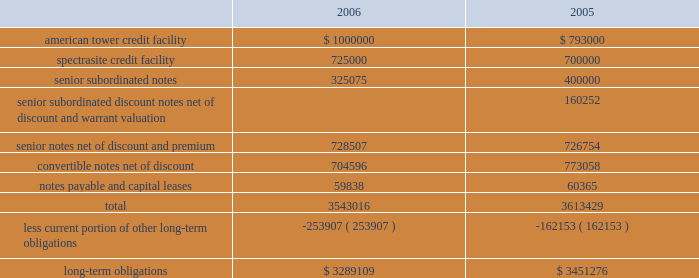American tower corporation and subsidiaries notes to consolidated financial statements 2014 ( continued ) 7 .
Financing arrangements outstanding amounts under the company 2019s long-term financing arrangements consisted of the following as of december 31 , ( in thousands ) : .
Credit facilities 2014in october 2005 , the company refinanced the two existing credit facilities of its principal operating subsidiaries .
The company replaced the existing american tower $ 1.1 billion senior secured credit facility with a new $ 1.3 billion senior secured credit facility and replaced the existing spectrasite $ 900.0 million senior secured credit facility with a new $ 1.15 billion senior secured credit facility .
In february 2007 , the company secured an additional $ 550.0 million under its credit facilities and drew down $ 250.0 million of the existing revolving loans under the american tower credit facility .
( see note 19. ) during the year ended december 31 , 2006 , the company drew down the remaining amount available under the delayed draw term loan component of the american tower credit facility and drew down $ 25.0 million of the delayed draw term loan component of the spectrasite credit facility to finance debt redemptions and repurchases .
In addition , on october 27 , 2006 , the remaining $ 175.0 million undrawn portion of the delayed draw term loan component of the spectrasite facility was canceled pursuant to its terms .
As of december 31 , 2006 , the american tower credit facility consists of the following : 2022 a $ 300.0 million revolving credit facility , against which approximately $ 17.8 million of undrawn letters of credit are outstanding at december 31 , 2006 , maturing on october 27 , 2010 ; 2022 a $ 750.0 million term loan a , which is fully drawn , maturing on october 27 , 2010 ; and 2022 a $ 250.0 million delayed draw term loan , which is fully drawn , maturing on october 27 , 2010 .
The borrowers under the american tower credit facility include ati , american tower , l.p. , american tower international , inc .
And american tower llc .
The company and the borrowers 2019 restricted subsidiaries ( as defined in the loan agreement ) have guaranteed all of the loans under the credit facility .
These loans are secured by liens on and security interests in substantially all assets of the borrowers and the restricted subsidiaries , with a carrying value aggregating approximately $ 4.5 billion at december 31 , 2006 .
As of december 31 , 2006 , the spectrasite credit facility consists of the following : 2022 a $ 250.0 million revolving credit facility , against which approximately $ 4.6 million of undrawn letters of credit were outstanding at december 31 , 2006 , maturing on october 27 , 2010; .
What percentage of outstanding amounts under the company 2019s long-term financing arrangements is current as of december 31 , 2006? 
Computations: (253907 / 3543016)
Answer: 0.07166. 